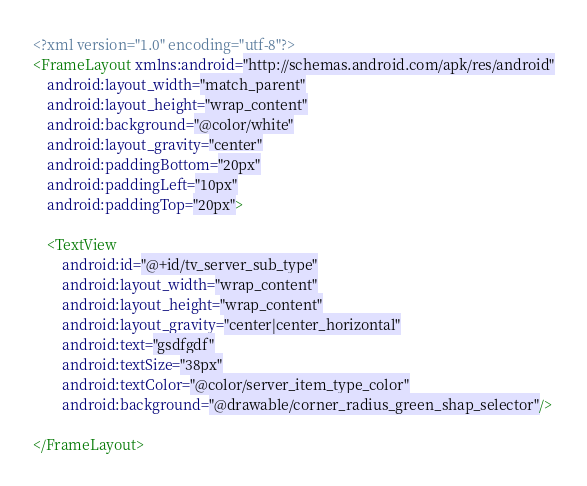<code> <loc_0><loc_0><loc_500><loc_500><_XML_><?xml version="1.0" encoding="utf-8"?>
<FrameLayout xmlns:android="http://schemas.android.com/apk/res/android"
    android:layout_width="match_parent"
    android:layout_height="wrap_content"
    android:background="@color/white"
    android:layout_gravity="center"
    android:paddingBottom="20px"
    android:paddingLeft="10px"
    android:paddingTop="20px">

    <TextView
        android:id="@+id/tv_server_sub_type"
        android:layout_width="wrap_content"
        android:layout_height="wrap_content"
        android:layout_gravity="center|center_horizontal"
        android:text="gsdfgdf"
        android:textSize="38px"
        android:textColor="@color/server_item_type_color"
        android:background="@drawable/corner_radius_green_shap_selector"/>

</FrameLayout></code> 